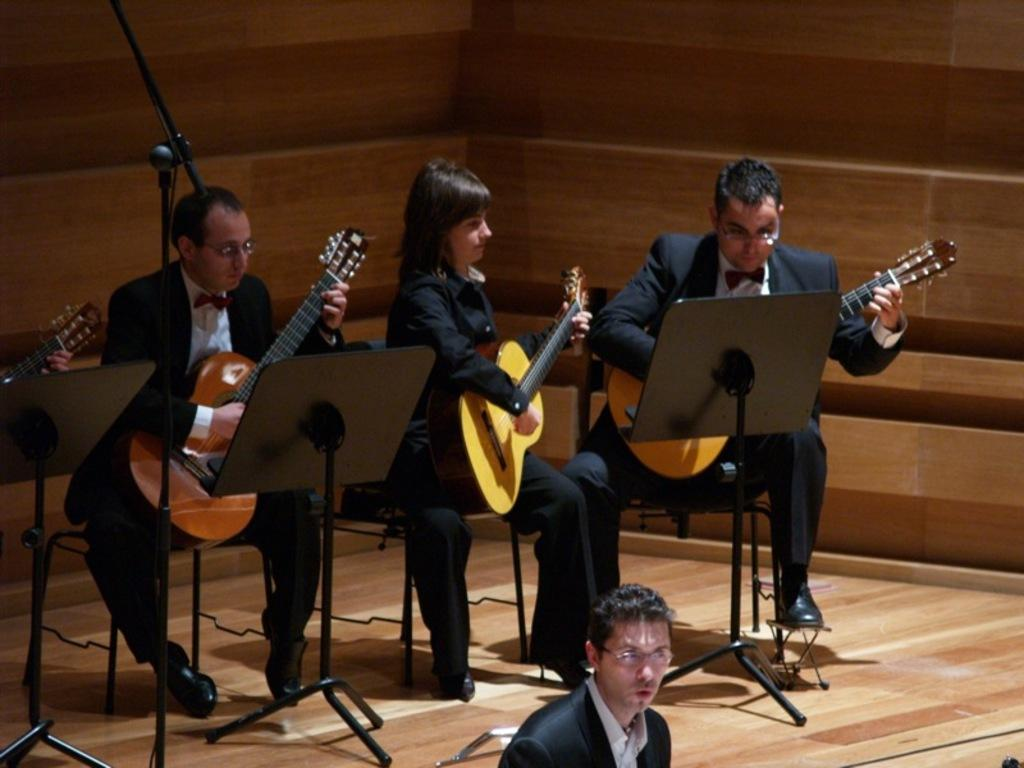How many people are in the image? There are three people in the image. What are the people in the image doing? The people are performing. Can you describe any musical instruments being played in the image? One or more of the people are playing a guitar. Where is the guide leading the group of people in the image? There is no guide present in the image; the people are performing. What type of owl can be seen in the image? There are no owls present in the image. 